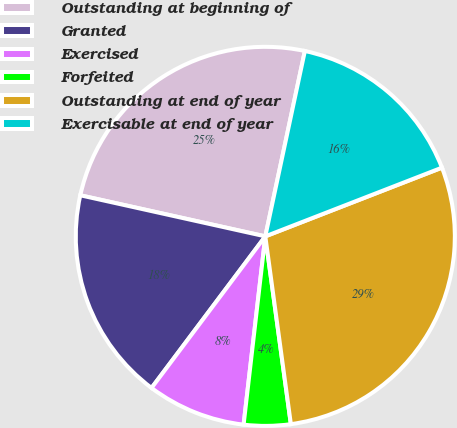<chart> <loc_0><loc_0><loc_500><loc_500><pie_chart><fcel>Outstanding at beginning of<fcel>Granted<fcel>Exercised<fcel>Forfeited<fcel>Outstanding at end of year<fcel>Exercisable at end of year<nl><fcel>24.87%<fcel>18.23%<fcel>8.42%<fcel>3.98%<fcel>28.75%<fcel>15.75%<nl></chart> 